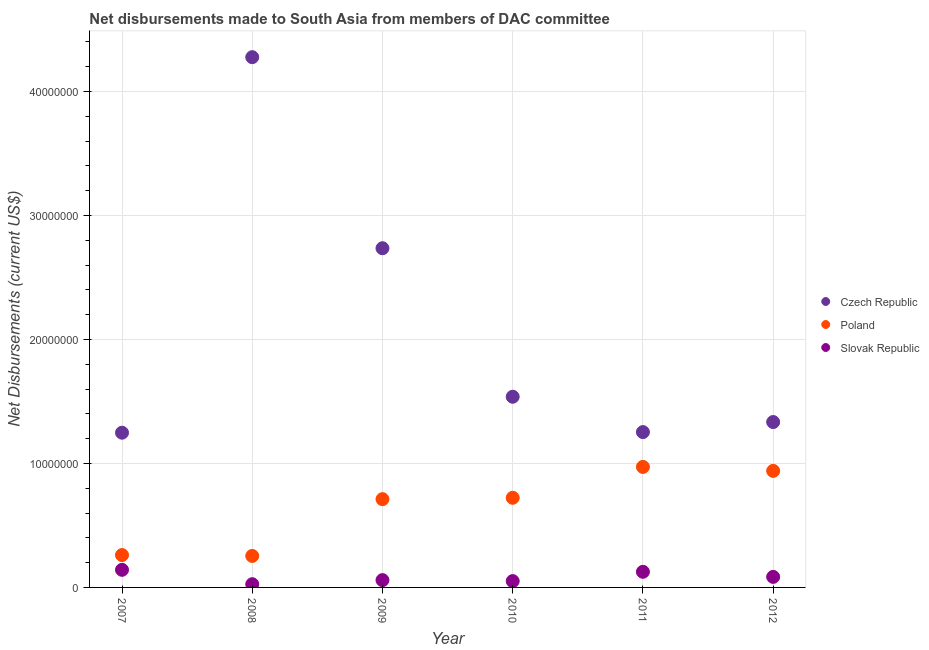What is the net disbursements made by czech republic in 2009?
Your answer should be compact. 2.74e+07. Across all years, what is the maximum net disbursements made by slovak republic?
Offer a very short reply. 1.42e+06. Across all years, what is the minimum net disbursements made by czech republic?
Ensure brevity in your answer.  1.25e+07. In which year was the net disbursements made by poland maximum?
Ensure brevity in your answer.  2011. In which year was the net disbursements made by poland minimum?
Provide a short and direct response. 2008. What is the total net disbursements made by slovak republic in the graph?
Provide a short and direct response. 4.89e+06. What is the difference between the net disbursements made by poland in 2008 and that in 2012?
Your answer should be compact. -6.86e+06. What is the difference between the net disbursements made by poland in 2011 and the net disbursements made by czech republic in 2009?
Your response must be concise. -1.76e+07. What is the average net disbursements made by poland per year?
Ensure brevity in your answer.  6.44e+06. In the year 2012, what is the difference between the net disbursements made by slovak republic and net disbursements made by poland?
Ensure brevity in your answer.  -8.55e+06. In how many years, is the net disbursements made by poland greater than 24000000 US$?
Provide a short and direct response. 0. What is the ratio of the net disbursements made by slovak republic in 2008 to that in 2012?
Offer a terse response. 0.31. Is the net disbursements made by poland in 2007 less than that in 2011?
Your answer should be very brief. Yes. What is the difference between the highest and the second highest net disbursements made by slovak republic?
Offer a terse response. 1.60e+05. What is the difference between the highest and the lowest net disbursements made by poland?
Your answer should be very brief. 7.18e+06. Is the sum of the net disbursements made by slovak republic in 2009 and 2010 greater than the maximum net disbursements made by czech republic across all years?
Give a very brief answer. No. Is it the case that in every year, the sum of the net disbursements made by czech republic and net disbursements made by poland is greater than the net disbursements made by slovak republic?
Your response must be concise. Yes. Does the net disbursements made by czech republic monotonically increase over the years?
Ensure brevity in your answer.  No. How many dotlines are there?
Offer a very short reply. 3. What is the difference between two consecutive major ticks on the Y-axis?
Ensure brevity in your answer.  1.00e+07. Does the graph contain grids?
Give a very brief answer. Yes. Where does the legend appear in the graph?
Ensure brevity in your answer.  Center right. How many legend labels are there?
Provide a short and direct response. 3. How are the legend labels stacked?
Make the answer very short. Vertical. What is the title of the graph?
Your answer should be very brief. Net disbursements made to South Asia from members of DAC committee. What is the label or title of the X-axis?
Ensure brevity in your answer.  Year. What is the label or title of the Y-axis?
Your answer should be very brief. Net Disbursements (current US$). What is the Net Disbursements (current US$) of Czech Republic in 2007?
Keep it short and to the point. 1.25e+07. What is the Net Disbursements (current US$) in Poland in 2007?
Provide a short and direct response. 2.61e+06. What is the Net Disbursements (current US$) in Slovak Republic in 2007?
Offer a terse response. 1.42e+06. What is the Net Disbursements (current US$) of Czech Republic in 2008?
Your response must be concise. 4.28e+07. What is the Net Disbursements (current US$) of Poland in 2008?
Offer a terse response. 2.54e+06. What is the Net Disbursements (current US$) in Slovak Republic in 2008?
Make the answer very short. 2.60e+05. What is the Net Disbursements (current US$) in Czech Republic in 2009?
Provide a short and direct response. 2.74e+07. What is the Net Disbursements (current US$) in Poland in 2009?
Provide a short and direct response. 7.12e+06. What is the Net Disbursements (current US$) in Slovak Republic in 2009?
Give a very brief answer. 5.90e+05. What is the Net Disbursements (current US$) of Czech Republic in 2010?
Provide a succinct answer. 1.54e+07. What is the Net Disbursements (current US$) in Poland in 2010?
Provide a succinct answer. 7.23e+06. What is the Net Disbursements (current US$) in Slovak Republic in 2010?
Provide a succinct answer. 5.10e+05. What is the Net Disbursements (current US$) in Czech Republic in 2011?
Offer a very short reply. 1.25e+07. What is the Net Disbursements (current US$) in Poland in 2011?
Offer a terse response. 9.72e+06. What is the Net Disbursements (current US$) in Slovak Republic in 2011?
Make the answer very short. 1.26e+06. What is the Net Disbursements (current US$) of Czech Republic in 2012?
Keep it short and to the point. 1.33e+07. What is the Net Disbursements (current US$) of Poland in 2012?
Your answer should be very brief. 9.40e+06. What is the Net Disbursements (current US$) in Slovak Republic in 2012?
Give a very brief answer. 8.50e+05. Across all years, what is the maximum Net Disbursements (current US$) in Czech Republic?
Make the answer very short. 4.28e+07. Across all years, what is the maximum Net Disbursements (current US$) in Poland?
Provide a succinct answer. 9.72e+06. Across all years, what is the maximum Net Disbursements (current US$) of Slovak Republic?
Make the answer very short. 1.42e+06. Across all years, what is the minimum Net Disbursements (current US$) in Czech Republic?
Offer a very short reply. 1.25e+07. Across all years, what is the minimum Net Disbursements (current US$) of Poland?
Your answer should be compact. 2.54e+06. What is the total Net Disbursements (current US$) in Czech Republic in the graph?
Keep it short and to the point. 1.24e+08. What is the total Net Disbursements (current US$) of Poland in the graph?
Keep it short and to the point. 3.86e+07. What is the total Net Disbursements (current US$) in Slovak Republic in the graph?
Make the answer very short. 4.89e+06. What is the difference between the Net Disbursements (current US$) in Czech Republic in 2007 and that in 2008?
Make the answer very short. -3.03e+07. What is the difference between the Net Disbursements (current US$) of Poland in 2007 and that in 2008?
Provide a succinct answer. 7.00e+04. What is the difference between the Net Disbursements (current US$) of Slovak Republic in 2007 and that in 2008?
Offer a terse response. 1.16e+06. What is the difference between the Net Disbursements (current US$) of Czech Republic in 2007 and that in 2009?
Ensure brevity in your answer.  -1.49e+07. What is the difference between the Net Disbursements (current US$) of Poland in 2007 and that in 2009?
Ensure brevity in your answer.  -4.51e+06. What is the difference between the Net Disbursements (current US$) of Slovak Republic in 2007 and that in 2009?
Your answer should be very brief. 8.30e+05. What is the difference between the Net Disbursements (current US$) in Czech Republic in 2007 and that in 2010?
Keep it short and to the point. -2.90e+06. What is the difference between the Net Disbursements (current US$) in Poland in 2007 and that in 2010?
Your answer should be very brief. -4.62e+06. What is the difference between the Net Disbursements (current US$) in Slovak Republic in 2007 and that in 2010?
Keep it short and to the point. 9.10e+05. What is the difference between the Net Disbursements (current US$) of Poland in 2007 and that in 2011?
Your answer should be compact. -7.11e+06. What is the difference between the Net Disbursements (current US$) in Slovak Republic in 2007 and that in 2011?
Give a very brief answer. 1.60e+05. What is the difference between the Net Disbursements (current US$) in Czech Republic in 2007 and that in 2012?
Provide a short and direct response. -8.60e+05. What is the difference between the Net Disbursements (current US$) of Poland in 2007 and that in 2012?
Provide a short and direct response. -6.79e+06. What is the difference between the Net Disbursements (current US$) in Slovak Republic in 2007 and that in 2012?
Provide a succinct answer. 5.70e+05. What is the difference between the Net Disbursements (current US$) in Czech Republic in 2008 and that in 2009?
Provide a succinct answer. 1.54e+07. What is the difference between the Net Disbursements (current US$) of Poland in 2008 and that in 2009?
Ensure brevity in your answer.  -4.58e+06. What is the difference between the Net Disbursements (current US$) in Slovak Republic in 2008 and that in 2009?
Provide a succinct answer. -3.30e+05. What is the difference between the Net Disbursements (current US$) in Czech Republic in 2008 and that in 2010?
Your answer should be very brief. 2.74e+07. What is the difference between the Net Disbursements (current US$) in Poland in 2008 and that in 2010?
Provide a succinct answer. -4.69e+06. What is the difference between the Net Disbursements (current US$) of Slovak Republic in 2008 and that in 2010?
Your response must be concise. -2.50e+05. What is the difference between the Net Disbursements (current US$) in Czech Republic in 2008 and that in 2011?
Your response must be concise. 3.02e+07. What is the difference between the Net Disbursements (current US$) in Poland in 2008 and that in 2011?
Offer a very short reply. -7.18e+06. What is the difference between the Net Disbursements (current US$) in Slovak Republic in 2008 and that in 2011?
Give a very brief answer. -1.00e+06. What is the difference between the Net Disbursements (current US$) in Czech Republic in 2008 and that in 2012?
Give a very brief answer. 2.94e+07. What is the difference between the Net Disbursements (current US$) of Poland in 2008 and that in 2012?
Keep it short and to the point. -6.86e+06. What is the difference between the Net Disbursements (current US$) of Slovak Republic in 2008 and that in 2012?
Provide a short and direct response. -5.90e+05. What is the difference between the Net Disbursements (current US$) in Czech Republic in 2009 and that in 2010?
Provide a succinct answer. 1.20e+07. What is the difference between the Net Disbursements (current US$) of Czech Republic in 2009 and that in 2011?
Your answer should be very brief. 1.48e+07. What is the difference between the Net Disbursements (current US$) of Poland in 2009 and that in 2011?
Provide a succinct answer. -2.60e+06. What is the difference between the Net Disbursements (current US$) of Slovak Republic in 2009 and that in 2011?
Offer a terse response. -6.70e+05. What is the difference between the Net Disbursements (current US$) of Czech Republic in 2009 and that in 2012?
Offer a terse response. 1.40e+07. What is the difference between the Net Disbursements (current US$) in Poland in 2009 and that in 2012?
Provide a short and direct response. -2.28e+06. What is the difference between the Net Disbursements (current US$) of Slovak Republic in 2009 and that in 2012?
Offer a very short reply. -2.60e+05. What is the difference between the Net Disbursements (current US$) in Czech Republic in 2010 and that in 2011?
Offer a terse response. 2.85e+06. What is the difference between the Net Disbursements (current US$) in Poland in 2010 and that in 2011?
Your response must be concise. -2.49e+06. What is the difference between the Net Disbursements (current US$) in Slovak Republic in 2010 and that in 2011?
Offer a very short reply. -7.50e+05. What is the difference between the Net Disbursements (current US$) of Czech Republic in 2010 and that in 2012?
Ensure brevity in your answer.  2.04e+06. What is the difference between the Net Disbursements (current US$) of Poland in 2010 and that in 2012?
Provide a succinct answer. -2.17e+06. What is the difference between the Net Disbursements (current US$) in Czech Republic in 2011 and that in 2012?
Your response must be concise. -8.10e+05. What is the difference between the Net Disbursements (current US$) of Poland in 2011 and that in 2012?
Your answer should be very brief. 3.20e+05. What is the difference between the Net Disbursements (current US$) of Slovak Republic in 2011 and that in 2012?
Provide a succinct answer. 4.10e+05. What is the difference between the Net Disbursements (current US$) in Czech Republic in 2007 and the Net Disbursements (current US$) in Poland in 2008?
Ensure brevity in your answer.  9.94e+06. What is the difference between the Net Disbursements (current US$) in Czech Republic in 2007 and the Net Disbursements (current US$) in Slovak Republic in 2008?
Ensure brevity in your answer.  1.22e+07. What is the difference between the Net Disbursements (current US$) in Poland in 2007 and the Net Disbursements (current US$) in Slovak Republic in 2008?
Offer a terse response. 2.35e+06. What is the difference between the Net Disbursements (current US$) of Czech Republic in 2007 and the Net Disbursements (current US$) of Poland in 2009?
Your answer should be compact. 5.36e+06. What is the difference between the Net Disbursements (current US$) of Czech Republic in 2007 and the Net Disbursements (current US$) of Slovak Republic in 2009?
Make the answer very short. 1.19e+07. What is the difference between the Net Disbursements (current US$) in Poland in 2007 and the Net Disbursements (current US$) in Slovak Republic in 2009?
Your answer should be very brief. 2.02e+06. What is the difference between the Net Disbursements (current US$) in Czech Republic in 2007 and the Net Disbursements (current US$) in Poland in 2010?
Your answer should be very brief. 5.25e+06. What is the difference between the Net Disbursements (current US$) in Czech Republic in 2007 and the Net Disbursements (current US$) in Slovak Republic in 2010?
Provide a succinct answer. 1.20e+07. What is the difference between the Net Disbursements (current US$) of Poland in 2007 and the Net Disbursements (current US$) of Slovak Republic in 2010?
Your response must be concise. 2.10e+06. What is the difference between the Net Disbursements (current US$) of Czech Republic in 2007 and the Net Disbursements (current US$) of Poland in 2011?
Keep it short and to the point. 2.76e+06. What is the difference between the Net Disbursements (current US$) in Czech Republic in 2007 and the Net Disbursements (current US$) in Slovak Republic in 2011?
Offer a terse response. 1.12e+07. What is the difference between the Net Disbursements (current US$) in Poland in 2007 and the Net Disbursements (current US$) in Slovak Republic in 2011?
Give a very brief answer. 1.35e+06. What is the difference between the Net Disbursements (current US$) of Czech Republic in 2007 and the Net Disbursements (current US$) of Poland in 2012?
Ensure brevity in your answer.  3.08e+06. What is the difference between the Net Disbursements (current US$) of Czech Republic in 2007 and the Net Disbursements (current US$) of Slovak Republic in 2012?
Keep it short and to the point. 1.16e+07. What is the difference between the Net Disbursements (current US$) of Poland in 2007 and the Net Disbursements (current US$) of Slovak Republic in 2012?
Offer a very short reply. 1.76e+06. What is the difference between the Net Disbursements (current US$) in Czech Republic in 2008 and the Net Disbursements (current US$) in Poland in 2009?
Give a very brief answer. 3.56e+07. What is the difference between the Net Disbursements (current US$) of Czech Republic in 2008 and the Net Disbursements (current US$) of Slovak Republic in 2009?
Your answer should be compact. 4.22e+07. What is the difference between the Net Disbursements (current US$) in Poland in 2008 and the Net Disbursements (current US$) in Slovak Republic in 2009?
Your answer should be compact. 1.95e+06. What is the difference between the Net Disbursements (current US$) of Czech Republic in 2008 and the Net Disbursements (current US$) of Poland in 2010?
Give a very brief answer. 3.55e+07. What is the difference between the Net Disbursements (current US$) of Czech Republic in 2008 and the Net Disbursements (current US$) of Slovak Republic in 2010?
Make the answer very short. 4.23e+07. What is the difference between the Net Disbursements (current US$) of Poland in 2008 and the Net Disbursements (current US$) of Slovak Republic in 2010?
Your answer should be compact. 2.03e+06. What is the difference between the Net Disbursements (current US$) of Czech Republic in 2008 and the Net Disbursements (current US$) of Poland in 2011?
Give a very brief answer. 3.30e+07. What is the difference between the Net Disbursements (current US$) of Czech Republic in 2008 and the Net Disbursements (current US$) of Slovak Republic in 2011?
Ensure brevity in your answer.  4.15e+07. What is the difference between the Net Disbursements (current US$) in Poland in 2008 and the Net Disbursements (current US$) in Slovak Republic in 2011?
Provide a succinct answer. 1.28e+06. What is the difference between the Net Disbursements (current US$) of Czech Republic in 2008 and the Net Disbursements (current US$) of Poland in 2012?
Provide a short and direct response. 3.34e+07. What is the difference between the Net Disbursements (current US$) in Czech Republic in 2008 and the Net Disbursements (current US$) in Slovak Republic in 2012?
Ensure brevity in your answer.  4.19e+07. What is the difference between the Net Disbursements (current US$) in Poland in 2008 and the Net Disbursements (current US$) in Slovak Republic in 2012?
Keep it short and to the point. 1.69e+06. What is the difference between the Net Disbursements (current US$) in Czech Republic in 2009 and the Net Disbursements (current US$) in Poland in 2010?
Give a very brief answer. 2.01e+07. What is the difference between the Net Disbursements (current US$) of Czech Republic in 2009 and the Net Disbursements (current US$) of Slovak Republic in 2010?
Offer a very short reply. 2.68e+07. What is the difference between the Net Disbursements (current US$) of Poland in 2009 and the Net Disbursements (current US$) of Slovak Republic in 2010?
Ensure brevity in your answer.  6.61e+06. What is the difference between the Net Disbursements (current US$) of Czech Republic in 2009 and the Net Disbursements (current US$) of Poland in 2011?
Your answer should be compact. 1.76e+07. What is the difference between the Net Disbursements (current US$) of Czech Republic in 2009 and the Net Disbursements (current US$) of Slovak Republic in 2011?
Ensure brevity in your answer.  2.61e+07. What is the difference between the Net Disbursements (current US$) of Poland in 2009 and the Net Disbursements (current US$) of Slovak Republic in 2011?
Offer a terse response. 5.86e+06. What is the difference between the Net Disbursements (current US$) in Czech Republic in 2009 and the Net Disbursements (current US$) in Poland in 2012?
Provide a succinct answer. 1.80e+07. What is the difference between the Net Disbursements (current US$) of Czech Republic in 2009 and the Net Disbursements (current US$) of Slovak Republic in 2012?
Give a very brief answer. 2.65e+07. What is the difference between the Net Disbursements (current US$) in Poland in 2009 and the Net Disbursements (current US$) in Slovak Republic in 2012?
Offer a terse response. 6.27e+06. What is the difference between the Net Disbursements (current US$) in Czech Republic in 2010 and the Net Disbursements (current US$) in Poland in 2011?
Provide a succinct answer. 5.66e+06. What is the difference between the Net Disbursements (current US$) in Czech Republic in 2010 and the Net Disbursements (current US$) in Slovak Republic in 2011?
Give a very brief answer. 1.41e+07. What is the difference between the Net Disbursements (current US$) in Poland in 2010 and the Net Disbursements (current US$) in Slovak Republic in 2011?
Your answer should be very brief. 5.97e+06. What is the difference between the Net Disbursements (current US$) of Czech Republic in 2010 and the Net Disbursements (current US$) of Poland in 2012?
Offer a very short reply. 5.98e+06. What is the difference between the Net Disbursements (current US$) in Czech Republic in 2010 and the Net Disbursements (current US$) in Slovak Republic in 2012?
Provide a succinct answer. 1.45e+07. What is the difference between the Net Disbursements (current US$) of Poland in 2010 and the Net Disbursements (current US$) of Slovak Republic in 2012?
Offer a terse response. 6.38e+06. What is the difference between the Net Disbursements (current US$) in Czech Republic in 2011 and the Net Disbursements (current US$) in Poland in 2012?
Offer a very short reply. 3.13e+06. What is the difference between the Net Disbursements (current US$) in Czech Republic in 2011 and the Net Disbursements (current US$) in Slovak Republic in 2012?
Provide a short and direct response. 1.17e+07. What is the difference between the Net Disbursements (current US$) of Poland in 2011 and the Net Disbursements (current US$) of Slovak Republic in 2012?
Offer a very short reply. 8.87e+06. What is the average Net Disbursements (current US$) of Czech Republic per year?
Offer a very short reply. 2.06e+07. What is the average Net Disbursements (current US$) in Poland per year?
Your answer should be very brief. 6.44e+06. What is the average Net Disbursements (current US$) in Slovak Republic per year?
Offer a terse response. 8.15e+05. In the year 2007, what is the difference between the Net Disbursements (current US$) in Czech Republic and Net Disbursements (current US$) in Poland?
Ensure brevity in your answer.  9.87e+06. In the year 2007, what is the difference between the Net Disbursements (current US$) in Czech Republic and Net Disbursements (current US$) in Slovak Republic?
Give a very brief answer. 1.11e+07. In the year 2007, what is the difference between the Net Disbursements (current US$) of Poland and Net Disbursements (current US$) of Slovak Republic?
Your response must be concise. 1.19e+06. In the year 2008, what is the difference between the Net Disbursements (current US$) in Czech Republic and Net Disbursements (current US$) in Poland?
Provide a succinct answer. 4.02e+07. In the year 2008, what is the difference between the Net Disbursements (current US$) of Czech Republic and Net Disbursements (current US$) of Slovak Republic?
Your answer should be very brief. 4.25e+07. In the year 2008, what is the difference between the Net Disbursements (current US$) in Poland and Net Disbursements (current US$) in Slovak Republic?
Ensure brevity in your answer.  2.28e+06. In the year 2009, what is the difference between the Net Disbursements (current US$) of Czech Republic and Net Disbursements (current US$) of Poland?
Offer a terse response. 2.02e+07. In the year 2009, what is the difference between the Net Disbursements (current US$) of Czech Republic and Net Disbursements (current US$) of Slovak Republic?
Your answer should be very brief. 2.68e+07. In the year 2009, what is the difference between the Net Disbursements (current US$) of Poland and Net Disbursements (current US$) of Slovak Republic?
Your response must be concise. 6.53e+06. In the year 2010, what is the difference between the Net Disbursements (current US$) in Czech Republic and Net Disbursements (current US$) in Poland?
Offer a very short reply. 8.15e+06. In the year 2010, what is the difference between the Net Disbursements (current US$) in Czech Republic and Net Disbursements (current US$) in Slovak Republic?
Your response must be concise. 1.49e+07. In the year 2010, what is the difference between the Net Disbursements (current US$) of Poland and Net Disbursements (current US$) of Slovak Republic?
Make the answer very short. 6.72e+06. In the year 2011, what is the difference between the Net Disbursements (current US$) in Czech Republic and Net Disbursements (current US$) in Poland?
Ensure brevity in your answer.  2.81e+06. In the year 2011, what is the difference between the Net Disbursements (current US$) in Czech Republic and Net Disbursements (current US$) in Slovak Republic?
Ensure brevity in your answer.  1.13e+07. In the year 2011, what is the difference between the Net Disbursements (current US$) in Poland and Net Disbursements (current US$) in Slovak Republic?
Provide a short and direct response. 8.46e+06. In the year 2012, what is the difference between the Net Disbursements (current US$) in Czech Republic and Net Disbursements (current US$) in Poland?
Your answer should be very brief. 3.94e+06. In the year 2012, what is the difference between the Net Disbursements (current US$) of Czech Republic and Net Disbursements (current US$) of Slovak Republic?
Give a very brief answer. 1.25e+07. In the year 2012, what is the difference between the Net Disbursements (current US$) in Poland and Net Disbursements (current US$) in Slovak Republic?
Your answer should be very brief. 8.55e+06. What is the ratio of the Net Disbursements (current US$) in Czech Republic in 2007 to that in 2008?
Ensure brevity in your answer.  0.29. What is the ratio of the Net Disbursements (current US$) in Poland in 2007 to that in 2008?
Your answer should be compact. 1.03. What is the ratio of the Net Disbursements (current US$) in Slovak Republic in 2007 to that in 2008?
Your answer should be compact. 5.46. What is the ratio of the Net Disbursements (current US$) in Czech Republic in 2007 to that in 2009?
Offer a very short reply. 0.46. What is the ratio of the Net Disbursements (current US$) of Poland in 2007 to that in 2009?
Give a very brief answer. 0.37. What is the ratio of the Net Disbursements (current US$) in Slovak Republic in 2007 to that in 2009?
Your response must be concise. 2.41. What is the ratio of the Net Disbursements (current US$) of Czech Republic in 2007 to that in 2010?
Offer a very short reply. 0.81. What is the ratio of the Net Disbursements (current US$) in Poland in 2007 to that in 2010?
Offer a very short reply. 0.36. What is the ratio of the Net Disbursements (current US$) in Slovak Republic in 2007 to that in 2010?
Provide a succinct answer. 2.78. What is the ratio of the Net Disbursements (current US$) in Poland in 2007 to that in 2011?
Provide a succinct answer. 0.27. What is the ratio of the Net Disbursements (current US$) in Slovak Republic in 2007 to that in 2011?
Provide a short and direct response. 1.13. What is the ratio of the Net Disbursements (current US$) of Czech Republic in 2007 to that in 2012?
Your response must be concise. 0.94. What is the ratio of the Net Disbursements (current US$) in Poland in 2007 to that in 2012?
Provide a succinct answer. 0.28. What is the ratio of the Net Disbursements (current US$) of Slovak Republic in 2007 to that in 2012?
Your answer should be compact. 1.67. What is the ratio of the Net Disbursements (current US$) in Czech Republic in 2008 to that in 2009?
Offer a very short reply. 1.56. What is the ratio of the Net Disbursements (current US$) in Poland in 2008 to that in 2009?
Provide a succinct answer. 0.36. What is the ratio of the Net Disbursements (current US$) of Slovak Republic in 2008 to that in 2009?
Make the answer very short. 0.44. What is the ratio of the Net Disbursements (current US$) in Czech Republic in 2008 to that in 2010?
Offer a terse response. 2.78. What is the ratio of the Net Disbursements (current US$) in Poland in 2008 to that in 2010?
Offer a terse response. 0.35. What is the ratio of the Net Disbursements (current US$) of Slovak Republic in 2008 to that in 2010?
Your answer should be very brief. 0.51. What is the ratio of the Net Disbursements (current US$) of Czech Republic in 2008 to that in 2011?
Your response must be concise. 3.41. What is the ratio of the Net Disbursements (current US$) in Poland in 2008 to that in 2011?
Offer a terse response. 0.26. What is the ratio of the Net Disbursements (current US$) of Slovak Republic in 2008 to that in 2011?
Offer a very short reply. 0.21. What is the ratio of the Net Disbursements (current US$) in Czech Republic in 2008 to that in 2012?
Provide a short and direct response. 3.21. What is the ratio of the Net Disbursements (current US$) in Poland in 2008 to that in 2012?
Give a very brief answer. 0.27. What is the ratio of the Net Disbursements (current US$) in Slovak Republic in 2008 to that in 2012?
Offer a very short reply. 0.31. What is the ratio of the Net Disbursements (current US$) in Czech Republic in 2009 to that in 2010?
Provide a short and direct response. 1.78. What is the ratio of the Net Disbursements (current US$) in Poland in 2009 to that in 2010?
Give a very brief answer. 0.98. What is the ratio of the Net Disbursements (current US$) of Slovak Republic in 2009 to that in 2010?
Offer a very short reply. 1.16. What is the ratio of the Net Disbursements (current US$) in Czech Republic in 2009 to that in 2011?
Make the answer very short. 2.18. What is the ratio of the Net Disbursements (current US$) in Poland in 2009 to that in 2011?
Offer a terse response. 0.73. What is the ratio of the Net Disbursements (current US$) of Slovak Republic in 2009 to that in 2011?
Offer a terse response. 0.47. What is the ratio of the Net Disbursements (current US$) of Czech Republic in 2009 to that in 2012?
Your response must be concise. 2.05. What is the ratio of the Net Disbursements (current US$) in Poland in 2009 to that in 2012?
Offer a very short reply. 0.76. What is the ratio of the Net Disbursements (current US$) in Slovak Republic in 2009 to that in 2012?
Your response must be concise. 0.69. What is the ratio of the Net Disbursements (current US$) in Czech Republic in 2010 to that in 2011?
Your response must be concise. 1.23. What is the ratio of the Net Disbursements (current US$) in Poland in 2010 to that in 2011?
Keep it short and to the point. 0.74. What is the ratio of the Net Disbursements (current US$) in Slovak Republic in 2010 to that in 2011?
Offer a terse response. 0.4. What is the ratio of the Net Disbursements (current US$) of Czech Republic in 2010 to that in 2012?
Make the answer very short. 1.15. What is the ratio of the Net Disbursements (current US$) in Poland in 2010 to that in 2012?
Your response must be concise. 0.77. What is the ratio of the Net Disbursements (current US$) of Czech Republic in 2011 to that in 2012?
Provide a succinct answer. 0.94. What is the ratio of the Net Disbursements (current US$) of Poland in 2011 to that in 2012?
Provide a short and direct response. 1.03. What is the ratio of the Net Disbursements (current US$) in Slovak Republic in 2011 to that in 2012?
Your answer should be very brief. 1.48. What is the difference between the highest and the second highest Net Disbursements (current US$) of Czech Republic?
Make the answer very short. 1.54e+07. What is the difference between the highest and the second highest Net Disbursements (current US$) of Poland?
Your response must be concise. 3.20e+05. What is the difference between the highest and the lowest Net Disbursements (current US$) in Czech Republic?
Your answer should be very brief. 3.03e+07. What is the difference between the highest and the lowest Net Disbursements (current US$) of Poland?
Make the answer very short. 7.18e+06. What is the difference between the highest and the lowest Net Disbursements (current US$) of Slovak Republic?
Provide a succinct answer. 1.16e+06. 